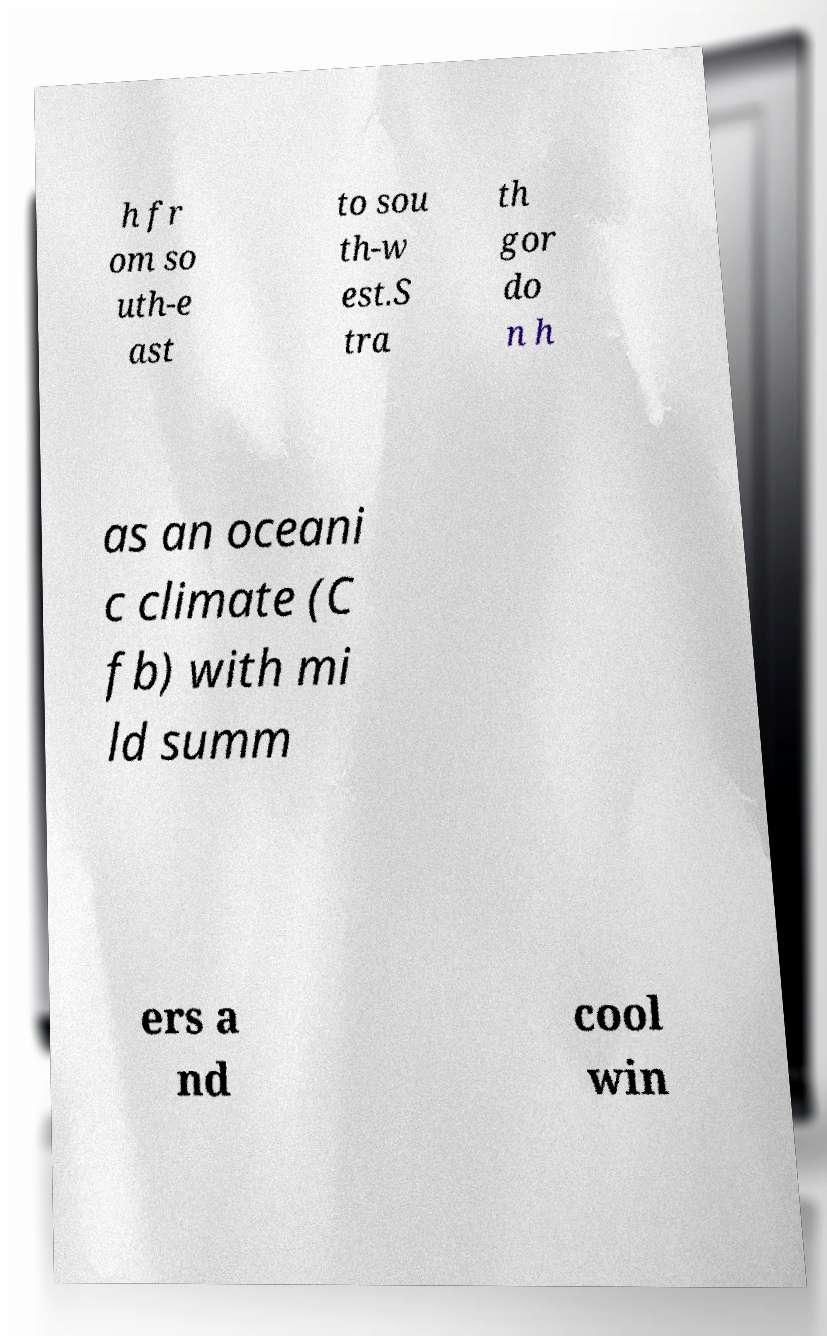Can you read and provide the text displayed in the image?This photo seems to have some interesting text. Can you extract and type it out for me? h fr om so uth-e ast to sou th-w est.S tra th gor do n h as an oceani c climate (C fb) with mi ld summ ers a nd cool win 